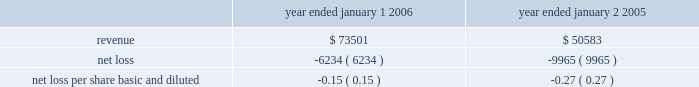In accordance with sfas no .
142 , goodwill and other intangible assets , the goodwill is not amortized , but will be subject to a periodic assessment for impairment by applying a fair-value-based test .
None of this goodwill is expected to be deductible for tax purposes .
The company performs its annual test for impairment of goodwill in may of each year .
The company is required to perform a periodic assessment between annual tests in certain circumstances .
The company has performed its annual test of goodwill as of may 1 , 2006 and has determined there was no impairment of goodwill during 2006 .
The company allocated $ 15.8 million of the purchase price to in-process research and development projects .
In-process research and development ( ipr&d ) represents the valuation of acquired , to-be- completed research projects .
At the acquisition date , cyvera 2019s ongoing research and development initiatives were primarily involved with the development of its veracode technology and the beadxpress reader .
These two projects were approximately 50% ( 50 % ) and 25% ( 25 % ) complete at the date of acquisition , respectively .
As of december 31 , 2006 , these two projects were approximately 90% ( 90 % ) and 80% ( 80 % ) complete , respectively .
The value assigned to purchased ipr&d was determined by estimating the costs to develop the acquired technology into commercially viable products , estimating the resulting net cash flows from the projects , and discounting the net cash flows to their present value .
The revenue projections used to value the ipr&d were , in some cases , reduced based on the probability of developing a new technology , and considered the relevant market sizes and growth factors , expected trends in technology , and the nature and expected timing of new product introductions by the company and its competitors .
The resulting net cash flows from such projects are based on the company 2019s estimates of cost of sales , operating expenses , and income taxes from such projects .
The rates utilized to discount the net cash flows to their present value were based on estimated cost of capital calculations .
Due to the nature of the forecast and the risks associated with the projected growth and profitability of the developmental projects , discount rates of 30% ( 30 % ) were considered appropriate for the ipr&d .
The company believes that these discount rates were commensurate with the projects 2019stage of development and the uncertainties in the economic estimates described above .
If these projects are not successfully developed , the sales and profitability of the combined company may be adversely affected in future periods .
The company believes that the foregoing assumptions used in the ipr&d analysis were reasonable at the time of the acquisition .
No assurance can be given , however , that the underlying assumptions used to estimate expected project sales , development costs or profitability , or the events associated with such projects , will transpire as estimated .
At the date of acquisition , the development of these projects had not yet reached technological feasibility , and the research and development in progress had no alternative future uses .
Accordingly , these costs were charged to expense in the second quarter of 2005 .
The following unaudited pro forma information shows the results of the company 2019s operations for the years ended january 1 , 2006 and january 2 , 2005 as though the acquisition had occurred as of the beginning of the periods presented ( in thousands , except per share data ) : year ended january 1 , year ended january 2 .
Illumina , inc .
Notes to consolidated financial statements 2014 ( continued ) .
What was the percentage change in net loss between 2005 and 2006? 
Computations: ((-6234 - -9965) / 9965)
Answer: 0.37441. 